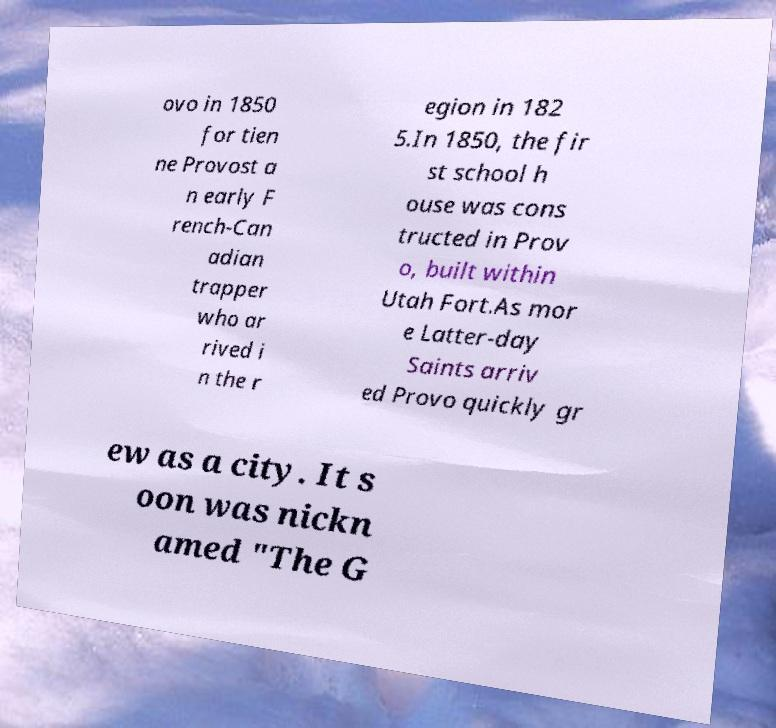What messages or text are displayed in this image? I need them in a readable, typed format. ovo in 1850 for tien ne Provost a n early F rench-Can adian trapper who ar rived i n the r egion in 182 5.In 1850, the fir st school h ouse was cons tructed in Prov o, built within Utah Fort.As mor e Latter-day Saints arriv ed Provo quickly gr ew as a city. It s oon was nickn amed "The G 